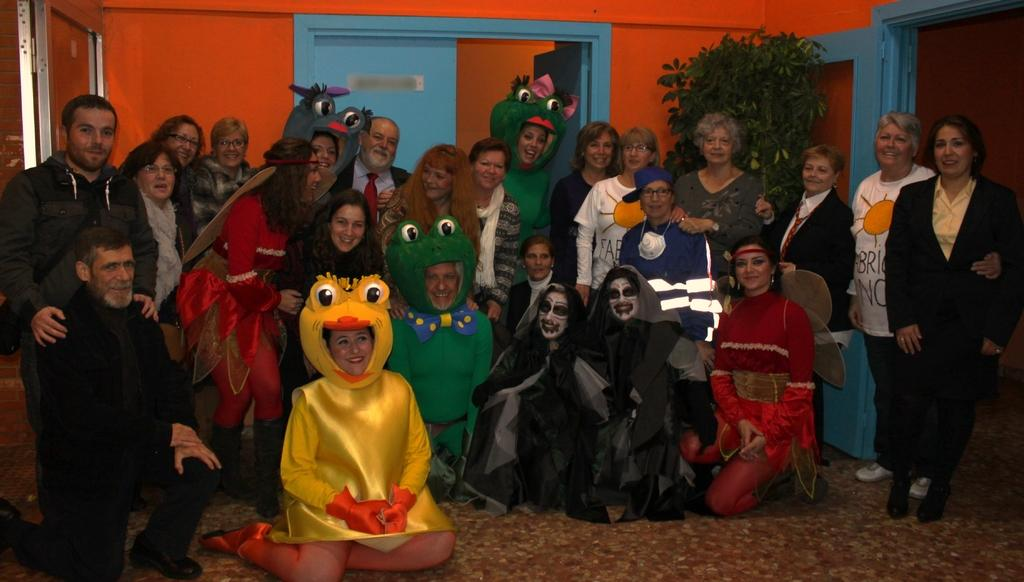How many people are in the group in the image? There is a group of people in the image, but the exact number is not specified. What are some people in the group wearing? Some people in the group are wearing fancy dress. What colors can be seen in the background of the image? There is an orange wall and a blue door in the background of the image. What type of vegetation is present in the background of the image? There is a plant in the background of the image. What type of soda is being served at the activity with friends in the image? There is no mention of friends, an activity, or soda in the image. The image only shows a group of people, some wearing fancy dress, and a background with an orange wall, blue door, and a plant. 